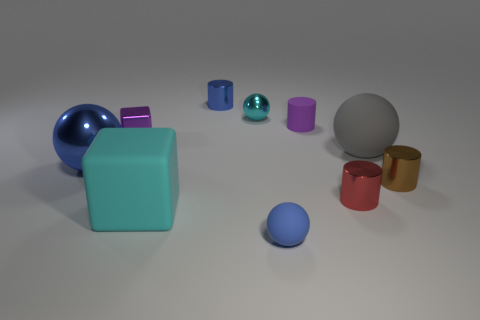Subtract all blue metal balls. How many balls are left? 3 Subtract 1 blocks. How many blocks are left? 1 Subtract all blue cylinders. How many cylinders are left? 3 Subtract 1 gray balls. How many objects are left? 9 Subtract all cubes. How many objects are left? 8 Subtract all gray cylinders. Subtract all red cubes. How many cylinders are left? 4 Subtract all red cubes. How many yellow cylinders are left? 0 Subtract all blue matte things. Subtract all gray matte things. How many objects are left? 8 Add 7 large gray things. How many large gray things are left? 8 Add 8 small red rubber cylinders. How many small red rubber cylinders exist? 8 